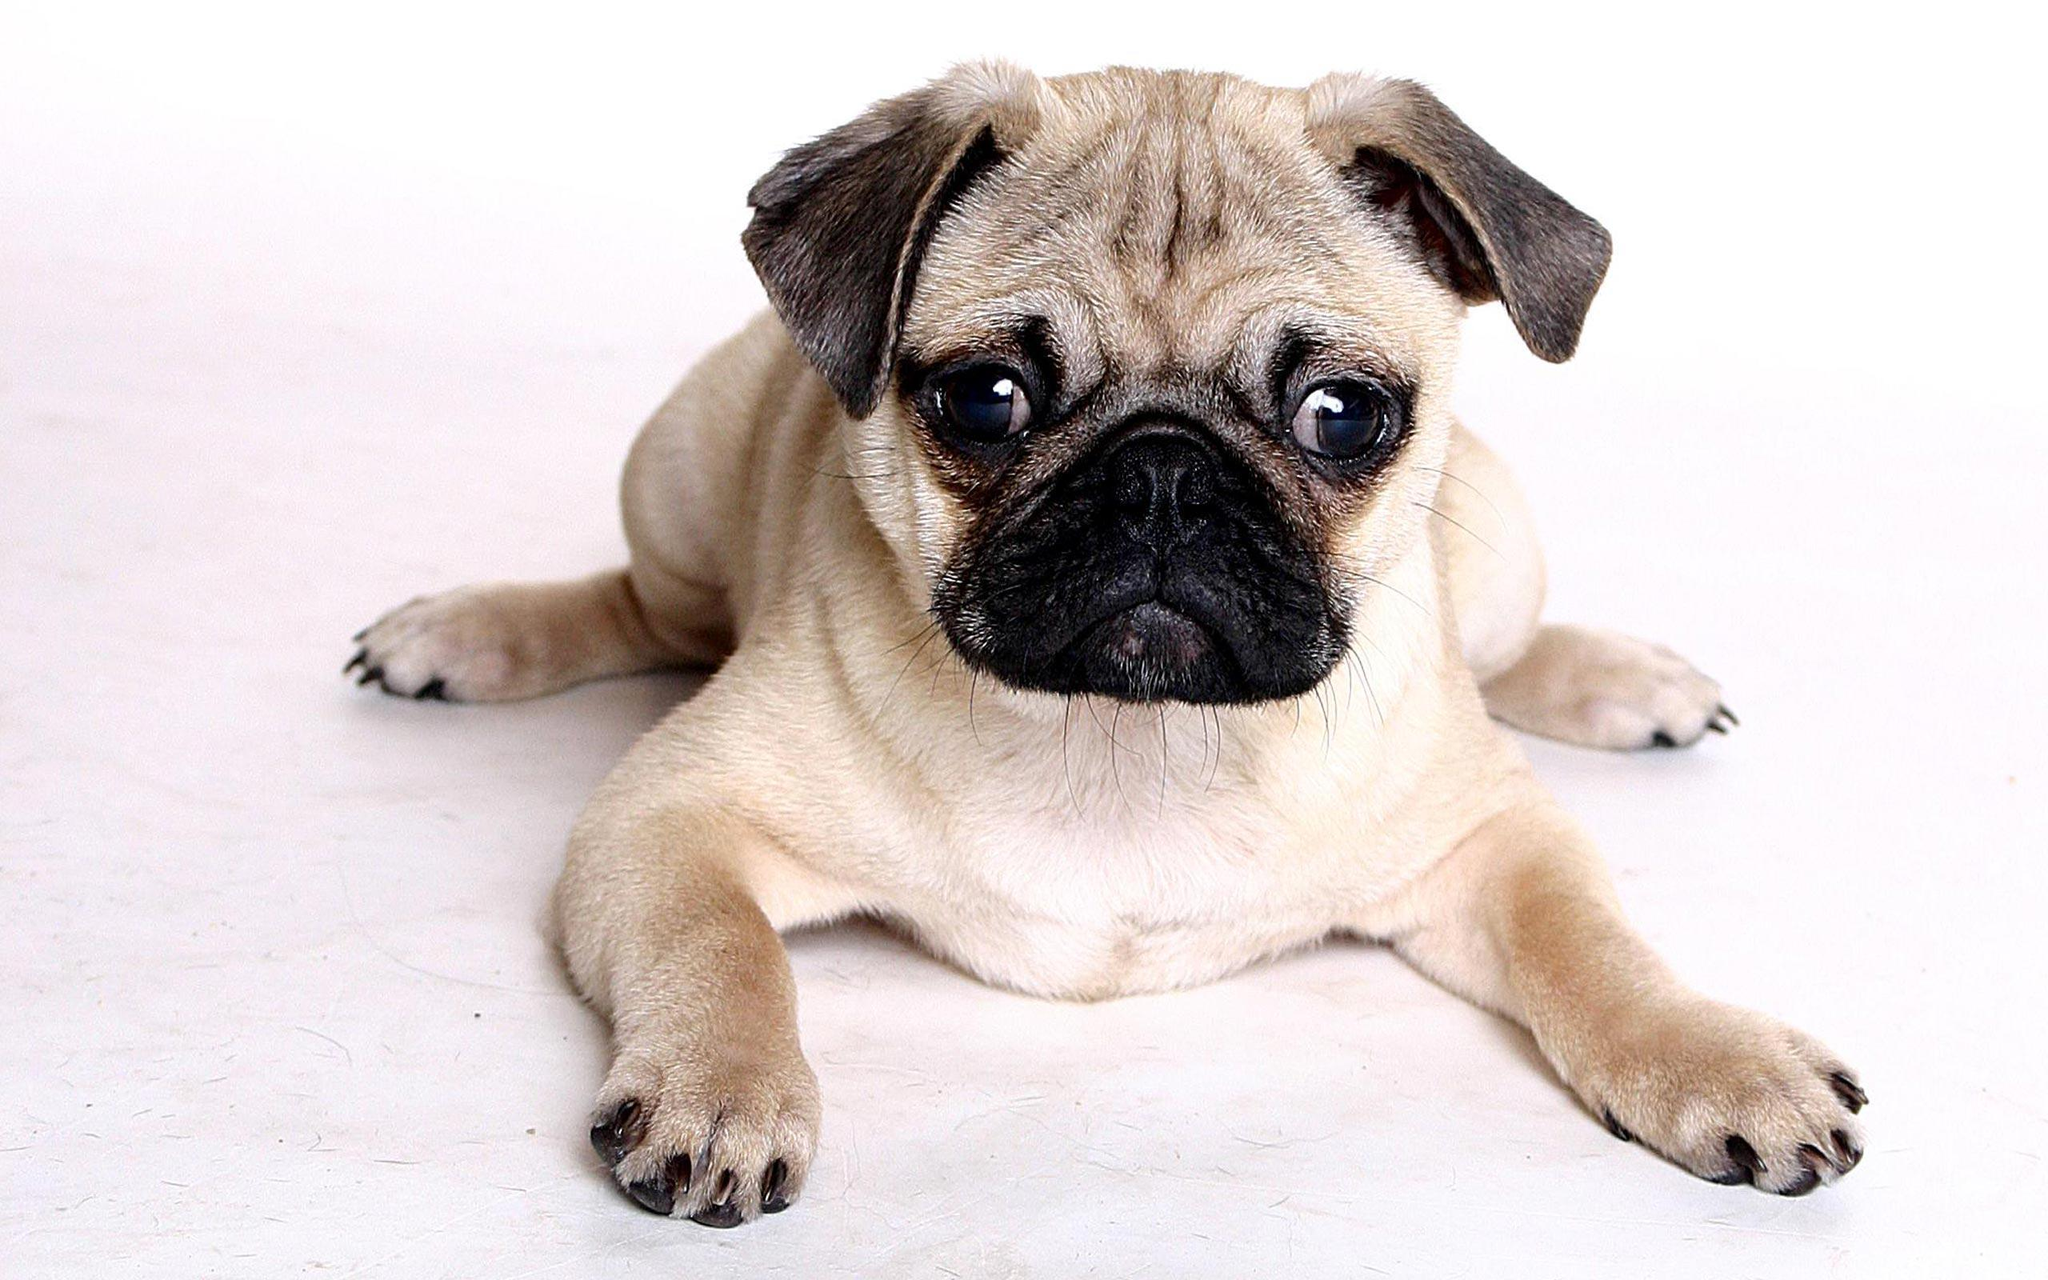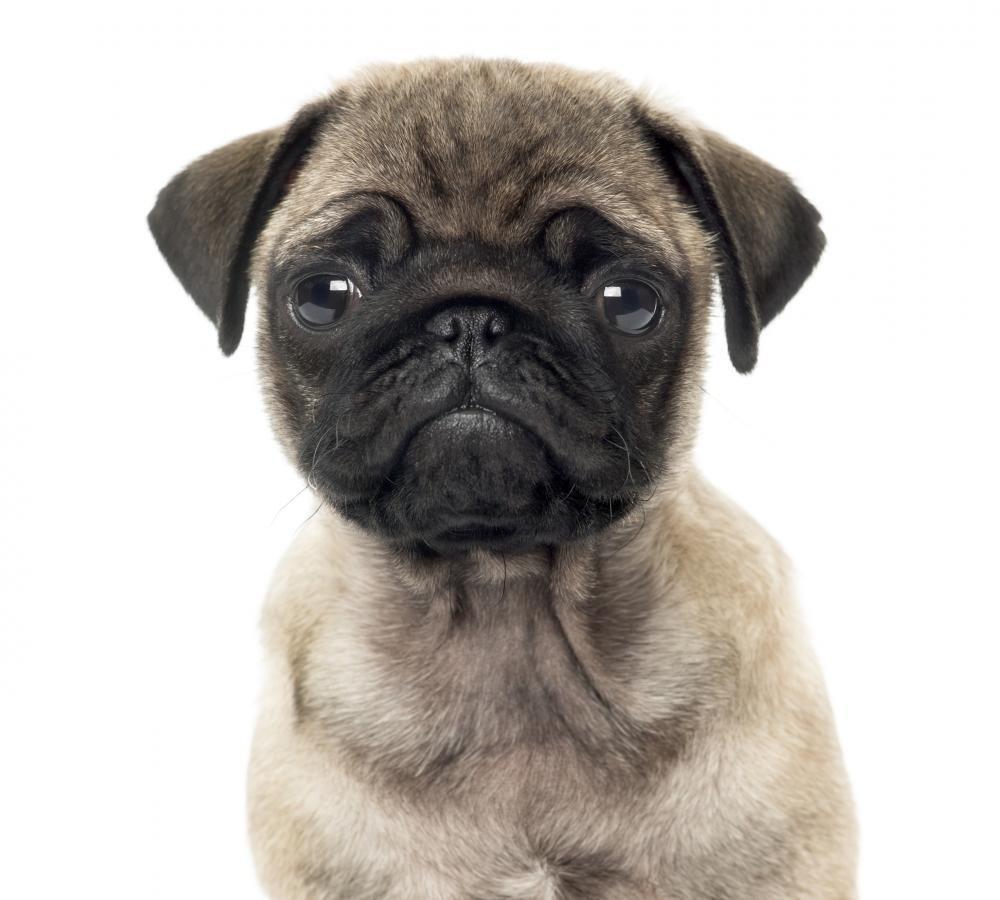The first image is the image on the left, the second image is the image on the right. Considering the images on both sides, is "The left image contains exactly one pug dog." valid? Answer yes or no. Yes. The first image is the image on the left, the second image is the image on the right. Considering the images on both sides, is "There is exactly one dog in every image and at least one dog is looking directly at the camera." valid? Answer yes or no. Yes. 